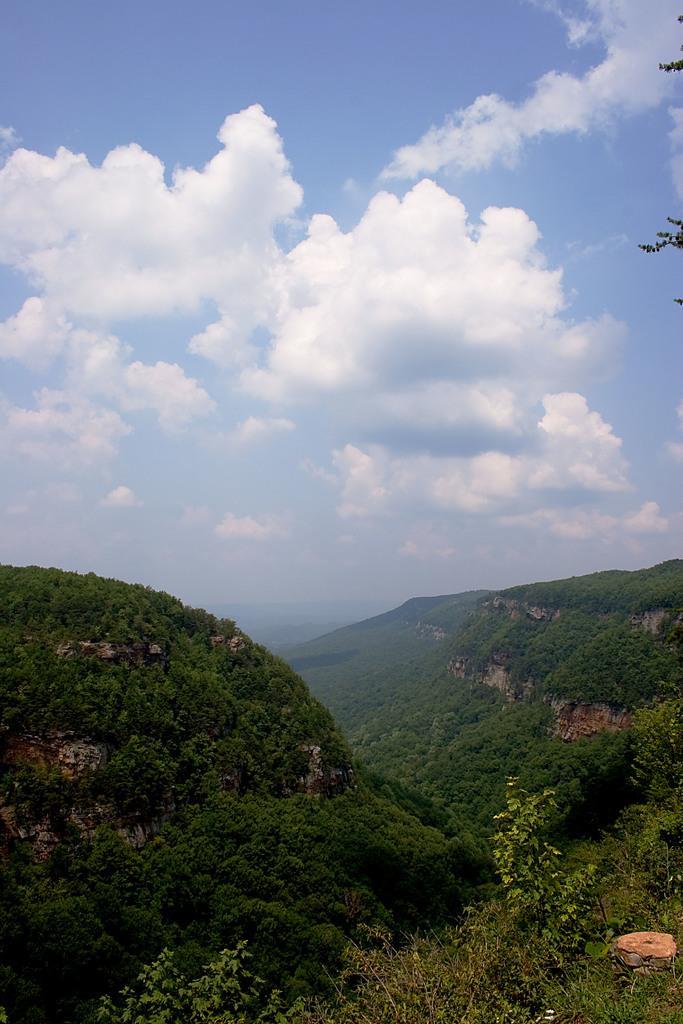How would you summarize this image in a sentence or two? In this image I can see trees, mountains and the sky. This image is taken may be near the mountains. 